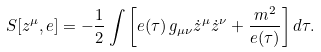<formula> <loc_0><loc_0><loc_500><loc_500>S [ z ^ { \mu } , e ] = - \frac { 1 } { 2 } \int \left [ e ( \tau ) \, g _ { \mu \nu } \dot { z } ^ { \mu } \dot { z } ^ { \nu } + \frac { m ^ { 2 } } { e ( \tau ) } \right ] d \tau .</formula> 